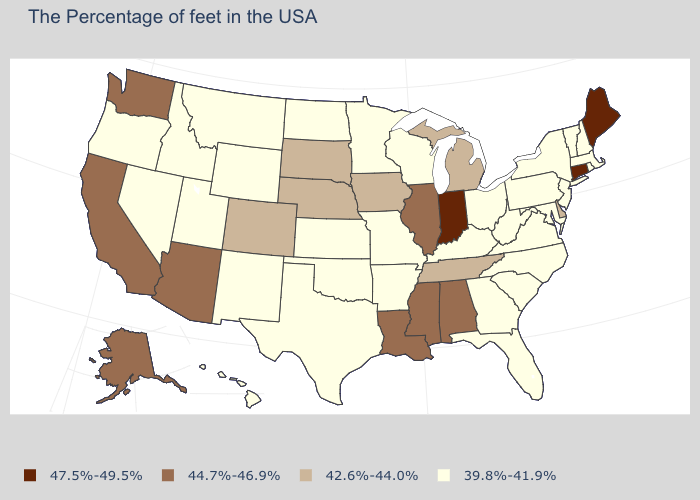What is the value of Missouri?
Quick response, please. 39.8%-41.9%. What is the value of Georgia?
Give a very brief answer. 39.8%-41.9%. Does the map have missing data?
Give a very brief answer. No. What is the value of Rhode Island?
Answer briefly. 39.8%-41.9%. Name the states that have a value in the range 42.6%-44.0%?
Answer briefly. Delaware, Michigan, Tennessee, Iowa, Nebraska, South Dakota, Colorado. What is the value of Maine?
Keep it brief. 47.5%-49.5%. Name the states that have a value in the range 42.6%-44.0%?
Quick response, please. Delaware, Michigan, Tennessee, Iowa, Nebraska, South Dakota, Colorado. What is the value of Oregon?
Be succinct. 39.8%-41.9%. What is the lowest value in states that border New Mexico?
Write a very short answer. 39.8%-41.9%. Does Illinois have a lower value than New Mexico?
Write a very short answer. No. Which states hav the highest value in the MidWest?
Write a very short answer. Indiana. Name the states that have a value in the range 39.8%-41.9%?
Keep it brief. Massachusetts, Rhode Island, New Hampshire, Vermont, New York, New Jersey, Maryland, Pennsylvania, Virginia, North Carolina, South Carolina, West Virginia, Ohio, Florida, Georgia, Kentucky, Wisconsin, Missouri, Arkansas, Minnesota, Kansas, Oklahoma, Texas, North Dakota, Wyoming, New Mexico, Utah, Montana, Idaho, Nevada, Oregon, Hawaii. What is the highest value in the MidWest ?
Be succinct. 47.5%-49.5%. Does Alaska have a lower value than Iowa?
Keep it brief. No. Which states have the highest value in the USA?
Write a very short answer. Maine, Connecticut, Indiana. 